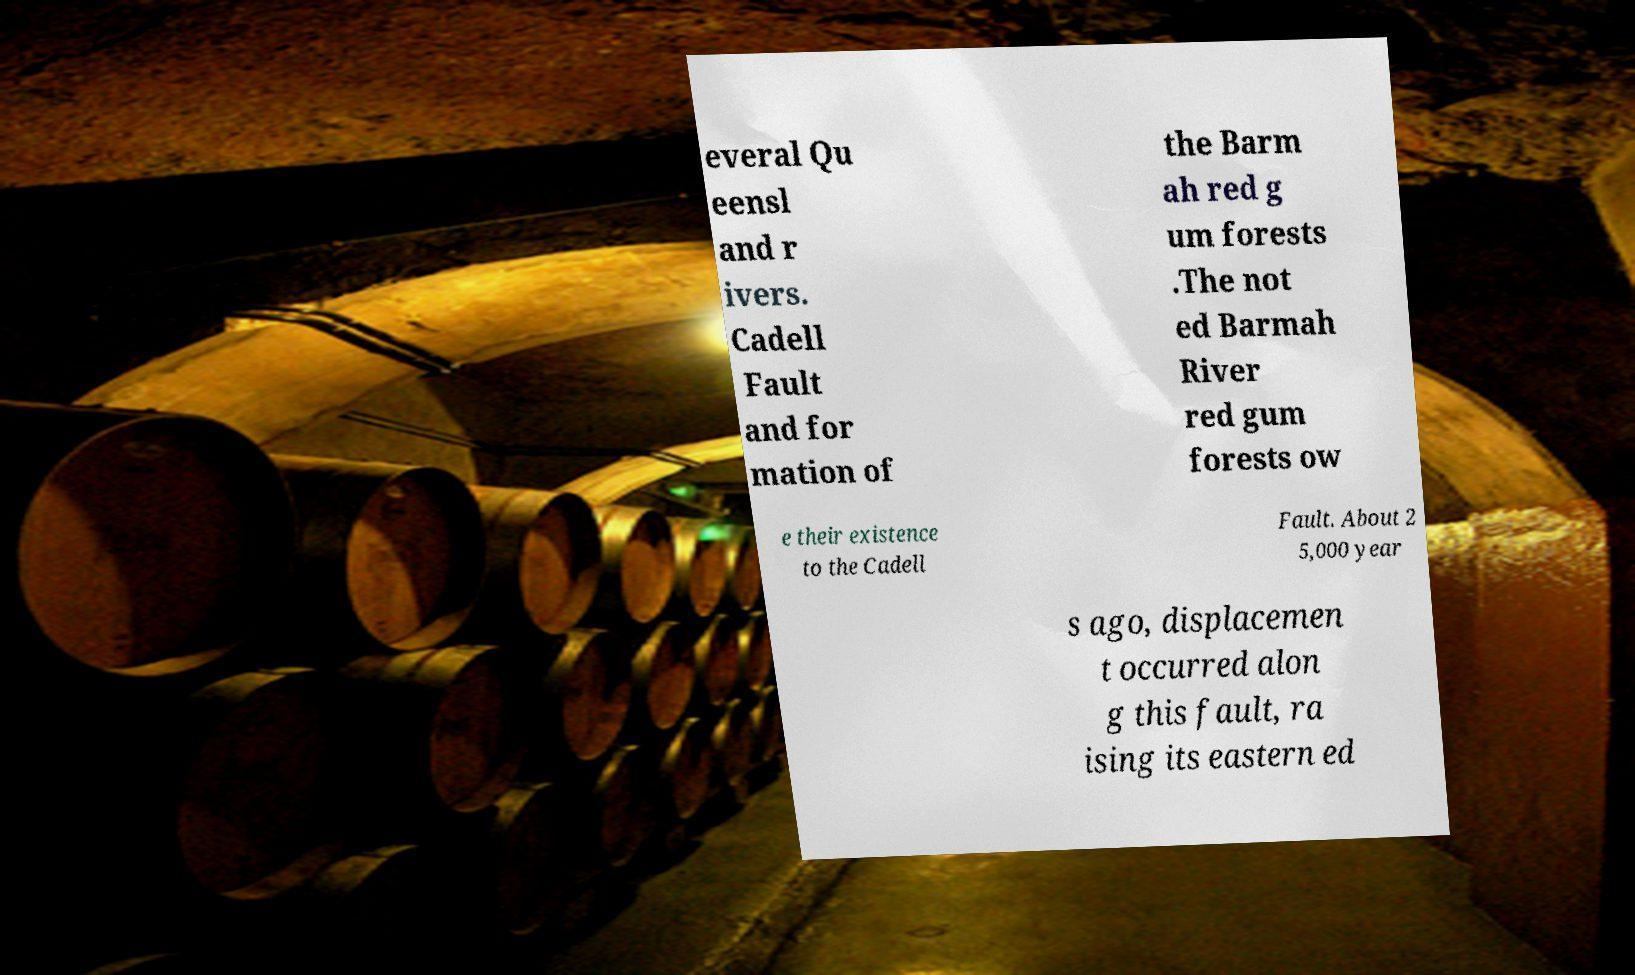Could you assist in decoding the text presented in this image and type it out clearly? everal Qu eensl and r ivers. Cadell Fault and for mation of the Barm ah red g um forests .The not ed Barmah River red gum forests ow e their existence to the Cadell Fault. About 2 5,000 year s ago, displacemen t occurred alon g this fault, ra ising its eastern ed 